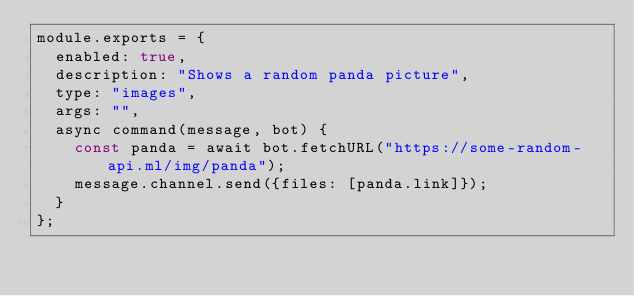Convert code to text. <code><loc_0><loc_0><loc_500><loc_500><_JavaScript_>module.exports = {
  enabled: true,
  description: "Shows a random panda picture",
  type: "images",
  args: "",
  async command(message, bot) {
    const panda = await bot.fetchURL("https://some-random-api.ml/img/panda");
    message.channel.send({files: [panda.link]});
  }
};
</code> 